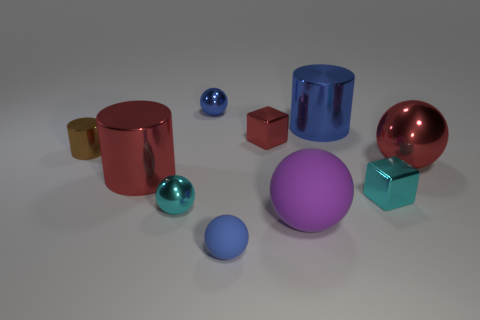Subtract 1 spheres. How many spheres are left? 4 Subtract all large purple balls. How many balls are left? 4 Subtract all purple balls. How many balls are left? 4 Subtract all green blocks. Subtract all brown cylinders. How many blocks are left? 2 Subtract all cylinders. How many objects are left? 7 Add 5 big brown spheres. How many big brown spheres exist? 5 Subtract 1 red balls. How many objects are left? 9 Subtract all small red metal objects. Subtract all blue balls. How many objects are left? 7 Add 6 tiny cyan metallic cubes. How many tiny cyan metallic cubes are left? 7 